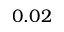<formula> <loc_0><loc_0><loc_500><loc_500>0 . 0 2</formula> 